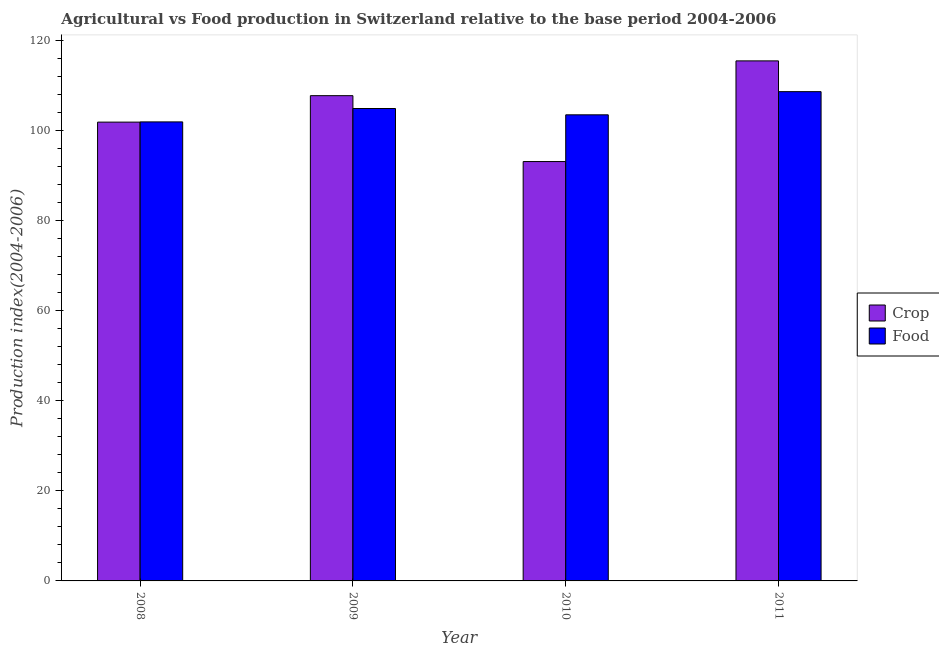How many different coloured bars are there?
Give a very brief answer. 2. How many bars are there on the 2nd tick from the left?
Provide a succinct answer. 2. What is the label of the 3rd group of bars from the left?
Your response must be concise. 2010. What is the crop production index in 2009?
Your answer should be compact. 107.68. Across all years, what is the maximum crop production index?
Offer a very short reply. 115.4. Across all years, what is the minimum crop production index?
Your answer should be compact. 93.06. What is the total crop production index in the graph?
Ensure brevity in your answer.  417.95. What is the difference between the food production index in 2008 and that in 2010?
Your answer should be compact. -1.57. What is the difference between the food production index in 2011 and the crop production index in 2009?
Your answer should be very brief. 3.74. What is the average food production index per year?
Keep it short and to the point. 104.67. In the year 2008, what is the difference between the food production index and crop production index?
Your answer should be compact. 0. What is the ratio of the food production index in 2009 to that in 2011?
Your response must be concise. 0.97. Is the food production index in 2009 less than that in 2011?
Your answer should be very brief. Yes. Is the difference between the food production index in 2008 and 2010 greater than the difference between the crop production index in 2008 and 2010?
Offer a terse response. No. What is the difference between the highest and the second highest crop production index?
Give a very brief answer. 7.72. What is the difference between the highest and the lowest food production index?
Ensure brevity in your answer.  6.71. In how many years, is the food production index greater than the average food production index taken over all years?
Offer a terse response. 2. What does the 1st bar from the left in 2008 represents?
Provide a succinct answer. Crop. What does the 2nd bar from the right in 2010 represents?
Keep it short and to the point. Crop. Are all the bars in the graph horizontal?
Provide a succinct answer. No. How many years are there in the graph?
Your answer should be compact. 4. Are the values on the major ticks of Y-axis written in scientific E-notation?
Give a very brief answer. No. Does the graph contain any zero values?
Offer a very short reply. No. Where does the legend appear in the graph?
Ensure brevity in your answer.  Center right. How many legend labels are there?
Offer a terse response. 2. How are the legend labels stacked?
Give a very brief answer. Vertical. What is the title of the graph?
Your answer should be very brief. Agricultural vs Food production in Switzerland relative to the base period 2004-2006. Does "Broad money growth" appear as one of the legend labels in the graph?
Provide a short and direct response. No. What is the label or title of the Y-axis?
Your answer should be very brief. Production index(2004-2006). What is the Production index(2004-2006) of Crop in 2008?
Your answer should be very brief. 101.81. What is the Production index(2004-2006) in Food in 2008?
Your answer should be very brief. 101.86. What is the Production index(2004-2006) of Crop in 2009?
Offer a very short reply. 107.68. What is the Production index(2004-2006) of Food in 2009?
Offer a terse response. 104.83. What is the Production index(2004-2006) in Crop in 2010?
Provide a succinct answer. 93.06. What is the Production index(2004-2006) of Food in 2010?
Provide a short and direct response. 103.43. What is the Production index(2004-2006) of Crop in 2011?
Provide a short and direct response. 115.4. What is the Production index(2004-2006) in Food in 2011?
Keep it short and to the point. 108.57. Across all years, what is the maximum Production index(2004-2006) of Crop?
Make the answer very short. 115.4. Across all years, what is the maximum Production index(2004-2006) of Food?
Provide a succinct answer. 108.57. Across all years, what is the minimum Production index(2004-2006) in Crop?
Make the answer very short. 93.06. Across all years, what is the minimum Production index(2004-2006) in Food?
Your answer should be compact. 101.86. What is the total Production index(2004-2006) of Crop in the graph?
Your answer should be compact. 417.95. What is the total Production index(2004-2006) in Food in the graph?
Make the answer very short. 418.69. What is the difference between the Production index(2004-2006) in Crop in 2008 and that in 2009?
Provide a short and direct response. -5.87. What is the difference between the Production index(2004-2006) of Food in 2008 and that in 2009?
Your answer should be very brief. -2.97. What is the difference between the Production index(2004-2006) in Crop in 2008 and that in 2010?
Keep it short and to the point. 8.75. What is the difference between the Production index(2004-2006) in Food in 2008 and that in 2010?
Your response must be concise. -1.57. What is the difference between the Production index(2004-2006) of Crop in 2008 and that in 2011?
Your response must be concise. -13.59. What is the difference between the Production index(2004-2006) of Food in 2008 and that in 2011?
Make the answer very short. -6.71. What is the difference between the Production index(2004-2006) of Crop in 2009 and that in 2010?
Provide a succinct answer. 14.62. What is the difference between the Production index(2004-2006) of Crop in 2009 and that in 2011?
Your answer should be compact. -7.72. What is the difference between the Production index(2004-2006) in Food in 2009 and that in 2011?
Ensure brevity in your answer.  -3.74. What is the difference between the Production index(2004-2006) in Crop in 2010 and that in 2011?
Provide a succinct answer. -22.34. What is the difference between the Production index(2004-2006) in Food in 2010 and that in 2011?
Offer a terse response. -5.14. What is the difference between the Production index(2004-2006) in Crop in 2008 and the Production index(2004-2006) in Food in 2009?
Provide a short and direct response. -3.02. What is the difference between the Production index(2004-2006) in Crop in 2008 and the Production index(2004-2006) in Food in 2010?
Offer a terse response. -1.62. What is the difference between the Production index(2004-2006) in Crop in 2008 and the Production index(2004-2006) in Food in 2011?
Make the answer very short. -6.76. What is the difference between the Production index(2004-2006) of Crop in 2009 and the Production index(2004-2006) of Food in 2010?
Your answer should be compact. 4.25. What is the difference between the Production index(2004-2006) of Crop in 2009 and the Production index(2004-2006) of Food in 2011?
Make the answer very short. -0.89. What is the difference between the Production index(2004-2006) of Crop in 2010 and the Production index(2004-2006) of Food in 2011?
Ensure brevity in your answer.  -15.51. What is the average Production index(2004-2006) in Crop per year?
Ensure brevity in your answer.  104.49. What is the average Production index(2004-2006) in Food per year?
Make the answer very short. 104.67. In the year 2008, what is the difference between the Production index(2004-2006) of Crop and Production index(2004-2006) of Food?
Your answer should be very brief. -0.05. In the year 2009, what is the difference between the Production index(2004-2006) in Crop and Production index(2004-2006) in Food?
Provide a short and direct response. 2.85. In the year 2010, what is the difference between the Production index(2004-2006) in Crop and Production index(2004-2006) in Food?
Offer a very short reply. -10.37. In the year 2011, what is the difference between the Production index(2004-2006) of Crop and Production index(2004-2006) of Food?
Make the answer very short. 6.83. What is the ratio of the Production index(2004-2006) in Crop in 2008 to that in 2009?
Keep it short and to the point. 0.95. What is the ratio of the Production index(2004-2006) of Food in 2008 to that in 2009?
Your response must be concise. 0.97. What is the ratio of the Production index(2004-2006) in Crop in 2008 to that in 2010?
Provide a short and direct response. 1.09. What is the ratio of the Production index(2004-2006) of Crop in 2008 to that in 2011?
Provide a succinct answer. 0.88. What is the ratio of the Production index(2004-2006) in Food in 2008 to that in 2011?
Give a very brief answer. 0.94. What is the ratio of the Production index(2004-2006) of Crop in 2009 to that in 2010?
Your answer should be very brief. 1.16. What is the ratio of the Production index(2004-2006) of Food in 2009 to that in 2010?
Provide a short and direct response. 1.01. What is the ratio of the Production index(2004-2006) of Crop in 2009 to that in 2011?
Your answer should be compact. 0.93. What is the ratio of the Production index(2004-2006) of Food in 2009 to that in 2011?
Give a very brief answer. 0.97. What is the ratio of the Production index(2004-2006) in Crop in 2010 to that in 2011?
Give a very brief answer. 0.81. What is the ratio of the Production index(2004-2006) in Food in 2010 to that in 2011?
Your answer should be very brief. 0.95. What is the difference between the highest and the second highest Production index(2004-2006) in Crop?
Keep it short and to the point. 7.72. What is the difference between the highest and the second highest Production index(2004-2006) in Food?
Keep it short and to the point. 3.74. What is the difference between the highest and the lowest Production index(2004-2006) in Crop?
Make the answer very short. 22.34. What is the difference between the highest and the lowest Production index(2004-2006) of Food?
Make the answer very short. 6.71. 